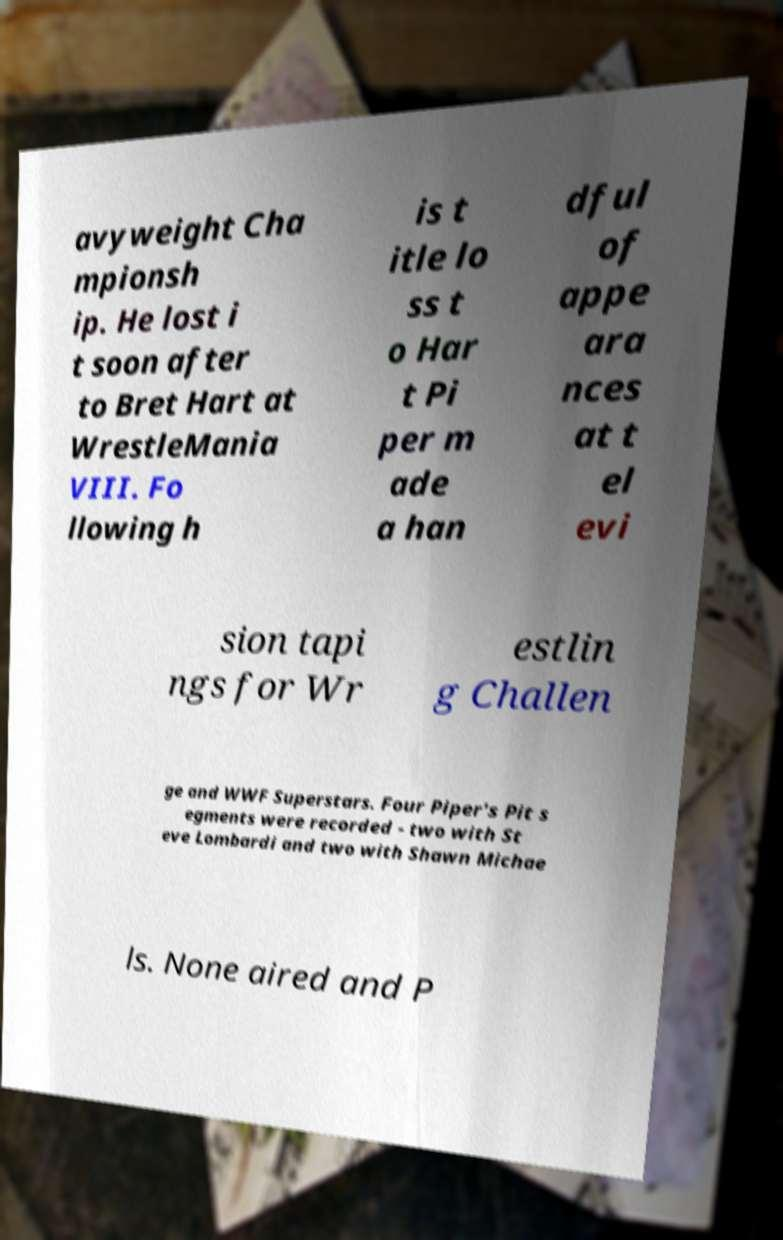Please read and relay the text visible in this image. What does it say? avyweight Cha mpionsh ip. He lost i t soon after to Bret Hart at WrestleMania VIII. Fo llowing h is t itle lo ss t o Har t Pi per m ade a han dful of appe ara nces at t el evi sion tapi ngs for Wr estlin g Challen ge and WWF Superstars. Four Piper's Pit s egments were recorded - two with St eve Lombardi and two with Shawn Michae ls. None aired and P 